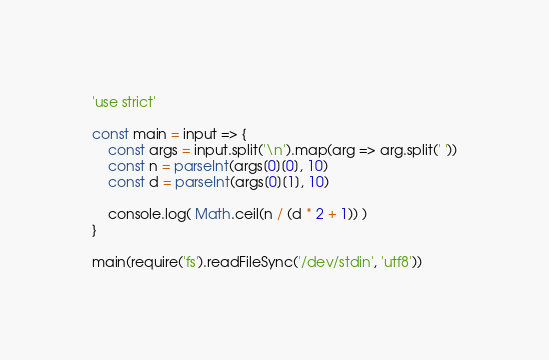Convert code to text. <code><loc_0><loc_0><loc_500><loc_500><_JavaScript_>'use strict'

const main = input => {
	const args = input.split('\n').map(arg => arg.split(' '))
	const n = parseInt(args[0][0], 10)
	const d = parseInt(args[0][1], 10)

	console.log( Math.ceil(n / (d * 2 + 1)) )
}

main(require('fs').readFileSync('/dev/stdin', 'utf8'))
</code> 